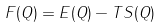Convert formula to latex. <formula><loc_0><loc_0><loc_500><loc_500>F ( Q ) = E ( Q ) - T S ( Q )</formula> 